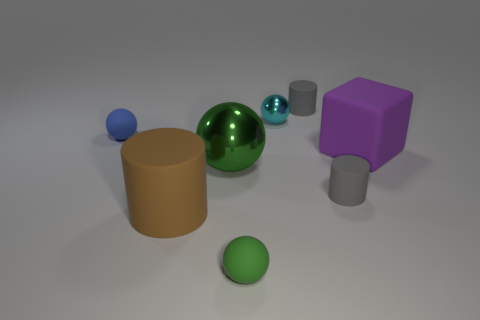Subtract all gray cylinders. How many were subtracted if there are1gray cylinders left? 1 Subtract all large brown matte cylinders. How many cylinders are left? 2 Subtract all brown cubes. How many green balls are left? 2 Add 1 tiny green rubber things. How many objects exist? 9 Subtract all brown cylinders. How many cylinders are left? 2 Subtract 2 spheres. How many spheres are left? 2 Subtract all cylinders. How many objects are left? 5 Subtract all red cylinders. Subtract all gray balls. How many cylinders are left? 3 Subtract all tiny brown things. Subtract all small metal things. How many objects are left? 7 Add 3 cyan metallic things. How many cyan metallic things are left? 4 